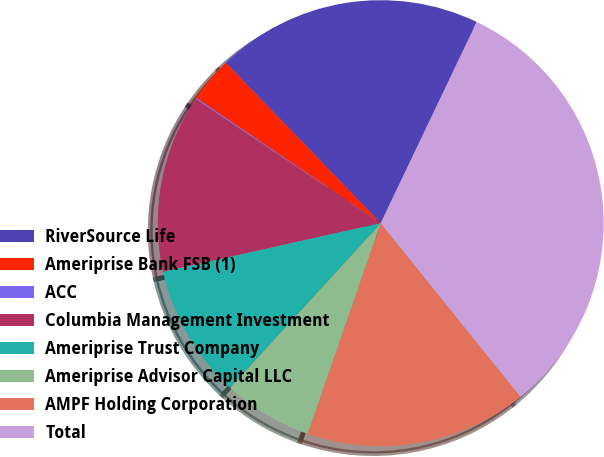Convert chart. <chart><loc_0><loc_0><loc_500><loc_500><pie_chart><fcel>RiverSource Life<fcel>Ameriprise Bank FSB (1)<fcel>ACC<fcel>Columbia Management Investment<fcel>Ameriprise Trust Company<fcel>Ameriprise Advisor Capital LLC<fcel>AMPF Holding Corporation<fcel>Total<nl><fcel>19.31%<fcel>3.29%<fcel>0.09%<fcel>12.9%<fcel>9.7%<fcel>6.49%<fcel>16.1%<fcel>32.12%<nl></chart> 